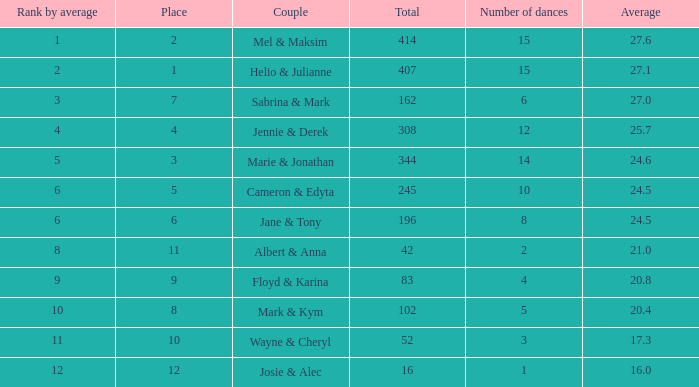What is the standing by average when the overall amount was greater than 245 and the average equaled 2 None. 